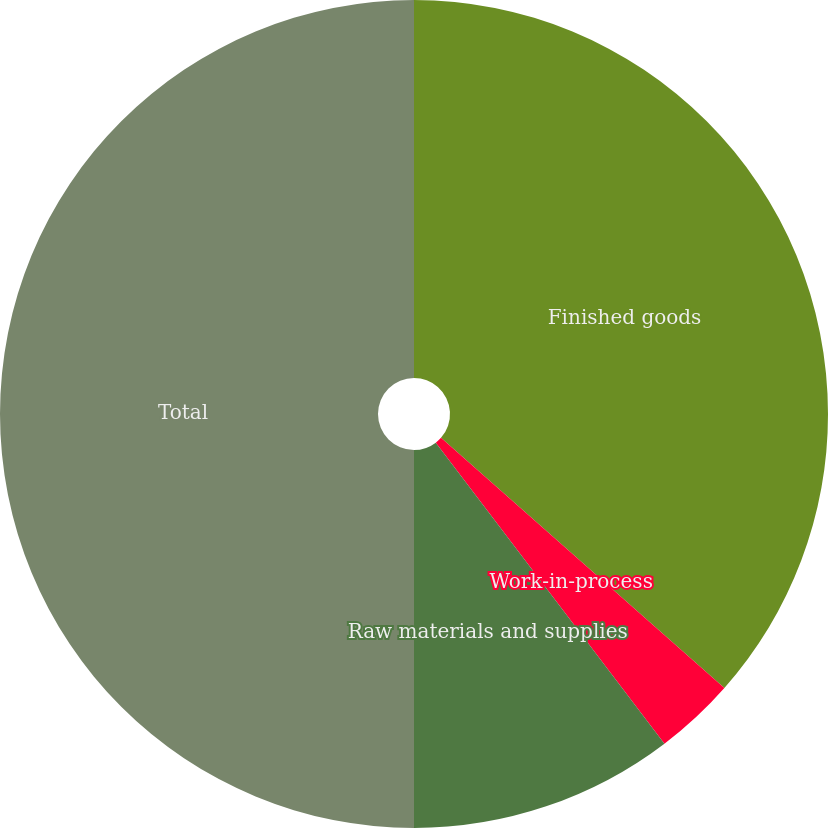<chart> <loc_0><loc_0><loc_500><loc_500><pie_chart><fcel>Finished goods<fcel>Work-in-process<fcel>Raw materials and supplies<fcel>Total<nl><fcel>36.51%<fcel>3.15%<fcel>10.34%<fcel>50.0%<nl></chart> 